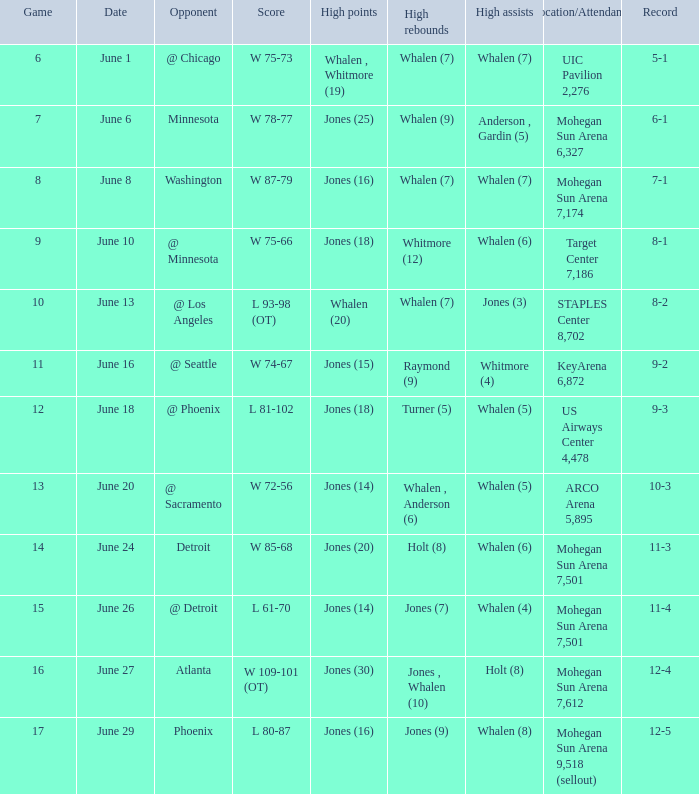What is the game on june 29? 17.0. 